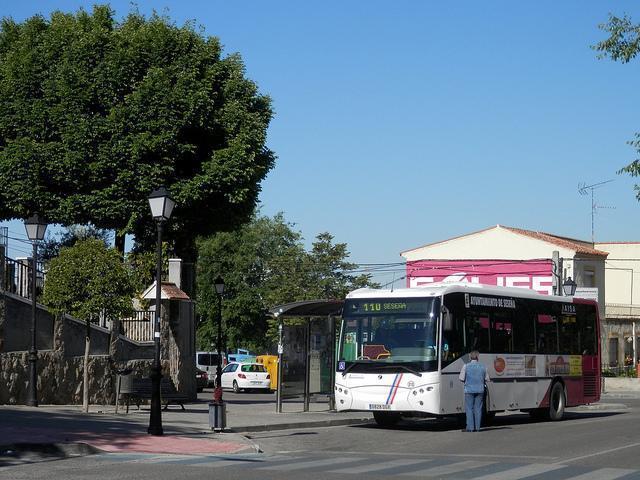During which weather would the bus stop here be most appreciated by riders?
Make your selection and explain in format: 'Answer: answer
Rationale: rationale.'
Options: Breezes, wind, clouds, rain. Answer: rain.
Rationale: The stop has a roof covering. 